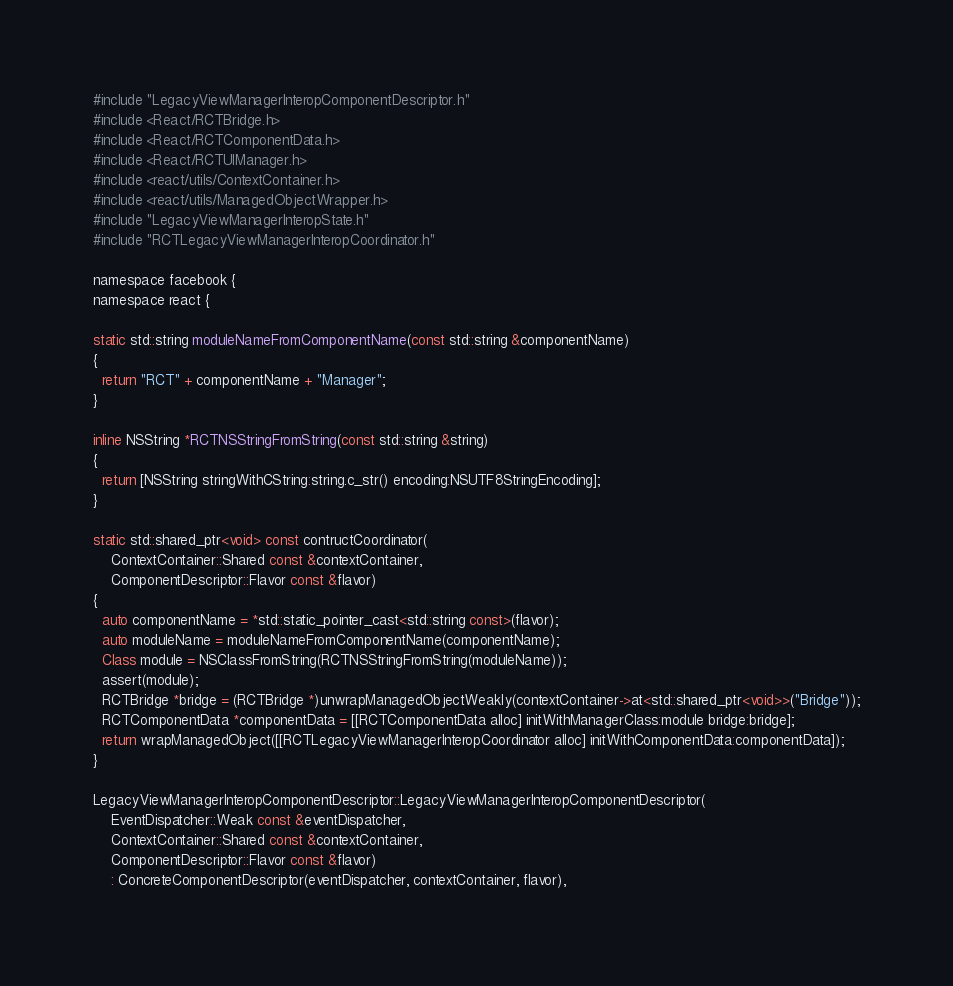Convert code to text. <code><loc_0><loc_0><loc_500><loc_500><_ObjectiveC_>#include "LegacyViewManagerInteropComponentDescriptor.h"
#include <React/RCTBridge.h>
#include <React/RCTComponentData.h>
#include <React/RCTUIManager.h>
#include <react/utils/ContextContainer.h>
#include <react/utils/ManagedObjectWrapper.h>
#include "LegacyViewManagerInteropState.h"
#include "RCTLegacyViewManagerInteropCoordinator.h"

namespace facebook {
namespace react {

static std::string moduleNameFromComponentName(const std::string &componentName)
{
  return "RCT" + componentName + "Manager";
}

inline NSString *RCTNSStringFromString(const std::string &string)
{
  return [NSString stringWithCString:string.c_str() encoding:NSUTF8StringEncoding];
}

static std::shared_ptr<void> const contructCoordinator(
    ContextContainer::Shared const &contextContainer,
    ComponentDescriptor::Flavor const &flavor)
{
  auto componentName = *std::static_pointer_cast<std::string const>(flavor);
  auto moduleName = moduleNameFromComponentName(componentName);
  Class module = NSClassFromString(RCTNSStringFromString(moduleName));
  assert(module);
  RCTBridge *bridge = (RCTBridge *)unwrapManagedObjectWeakly(contextContainer->at<std::shared_ptr<void>>("Bridge"));
  RCTComponentData *componentData = [[RCTComponentData alloc] initWithManagerClass:module bridge:bridge];
  return wrapManagedObject([[RCTLegacyViewManagerInteropCoordinator alloc] initWithComponentData:componentData]);
}

LegacyViewManagerInteropComponentDescriptor::LegacyViewManagerInteropComponentDescriptor(
    EventDispatcher::Weak const &eventDispatcher,
    ContextContainer::Shared const &contextContainer,
    ComponentDescriptor::Flavor const &flavor)
    : ConcreteComponentDescriptor(eventDispatcher, contextContainer, flavor),</code> 